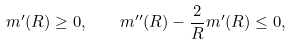<formula> <loc_0><loc_0><loc_500><loc_500>m ^ { \prime } ( R ) \geq 0 , \quad m ^ { \prime \prime } ( R ) - \frac { 2 } { R } m ^ { \prime } ( R ) \leq 0 ,</formula> 